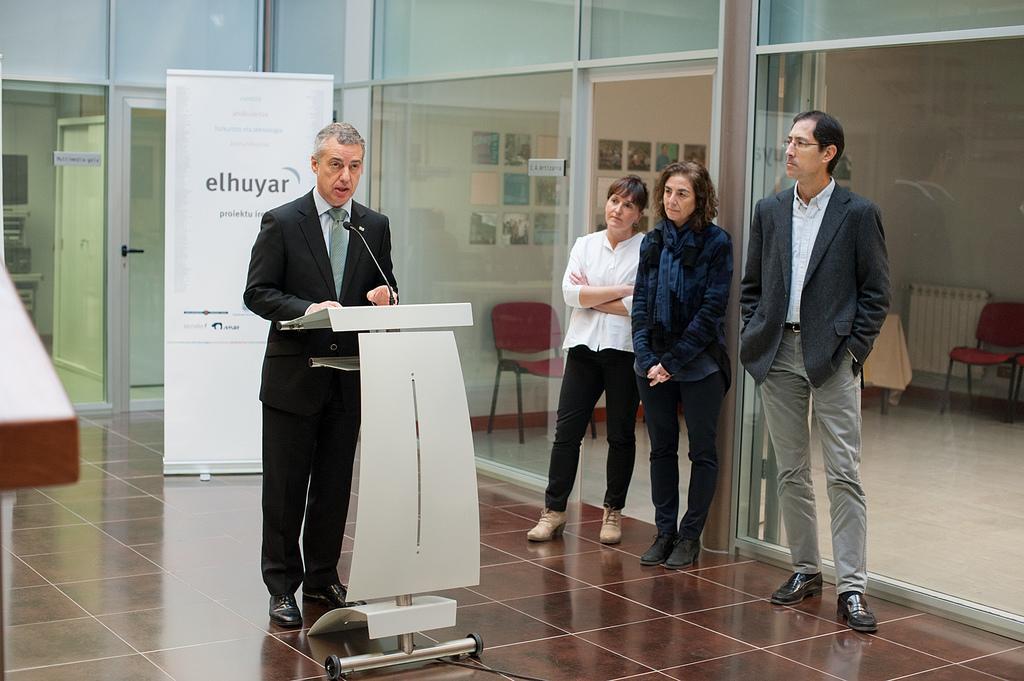Could you give a brief overview of what you see in this image? Here we can see four persons and he is talking on the mike. This is a podium and there is a banner. This is floor. Here we can see chairs, glasses, doors, and frames on the wall. 